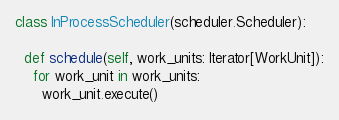<code> <loc_0><loc_0><loc_500><loc_500><_Python_>

class InProcessScheduler(scheduler.Scheduler):

  def schedule(self, work_units: Iterator[WorkUnit]):
    for work_unit in work_units:
      work_unit.execute()
</code> 